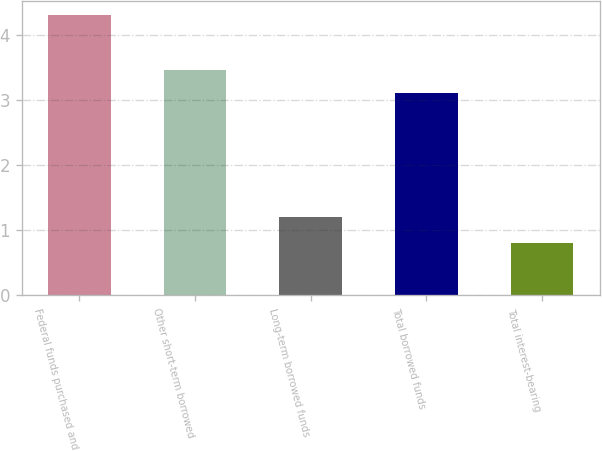Convert chart. <chart><loc_0><loc_0><loc_500><loc_500><bar_chart><fcel>Federal funds purchased and<fcel>Other short-term borrowed<fcel>Long-term borrowed funds<fcel>Total borrowed funds<fcel>Total interest-bearing<nl><fcel>4.31<fcel>3.46<fcel>1.2<fcel>3.11<fcel>0.8<nl></chart> 